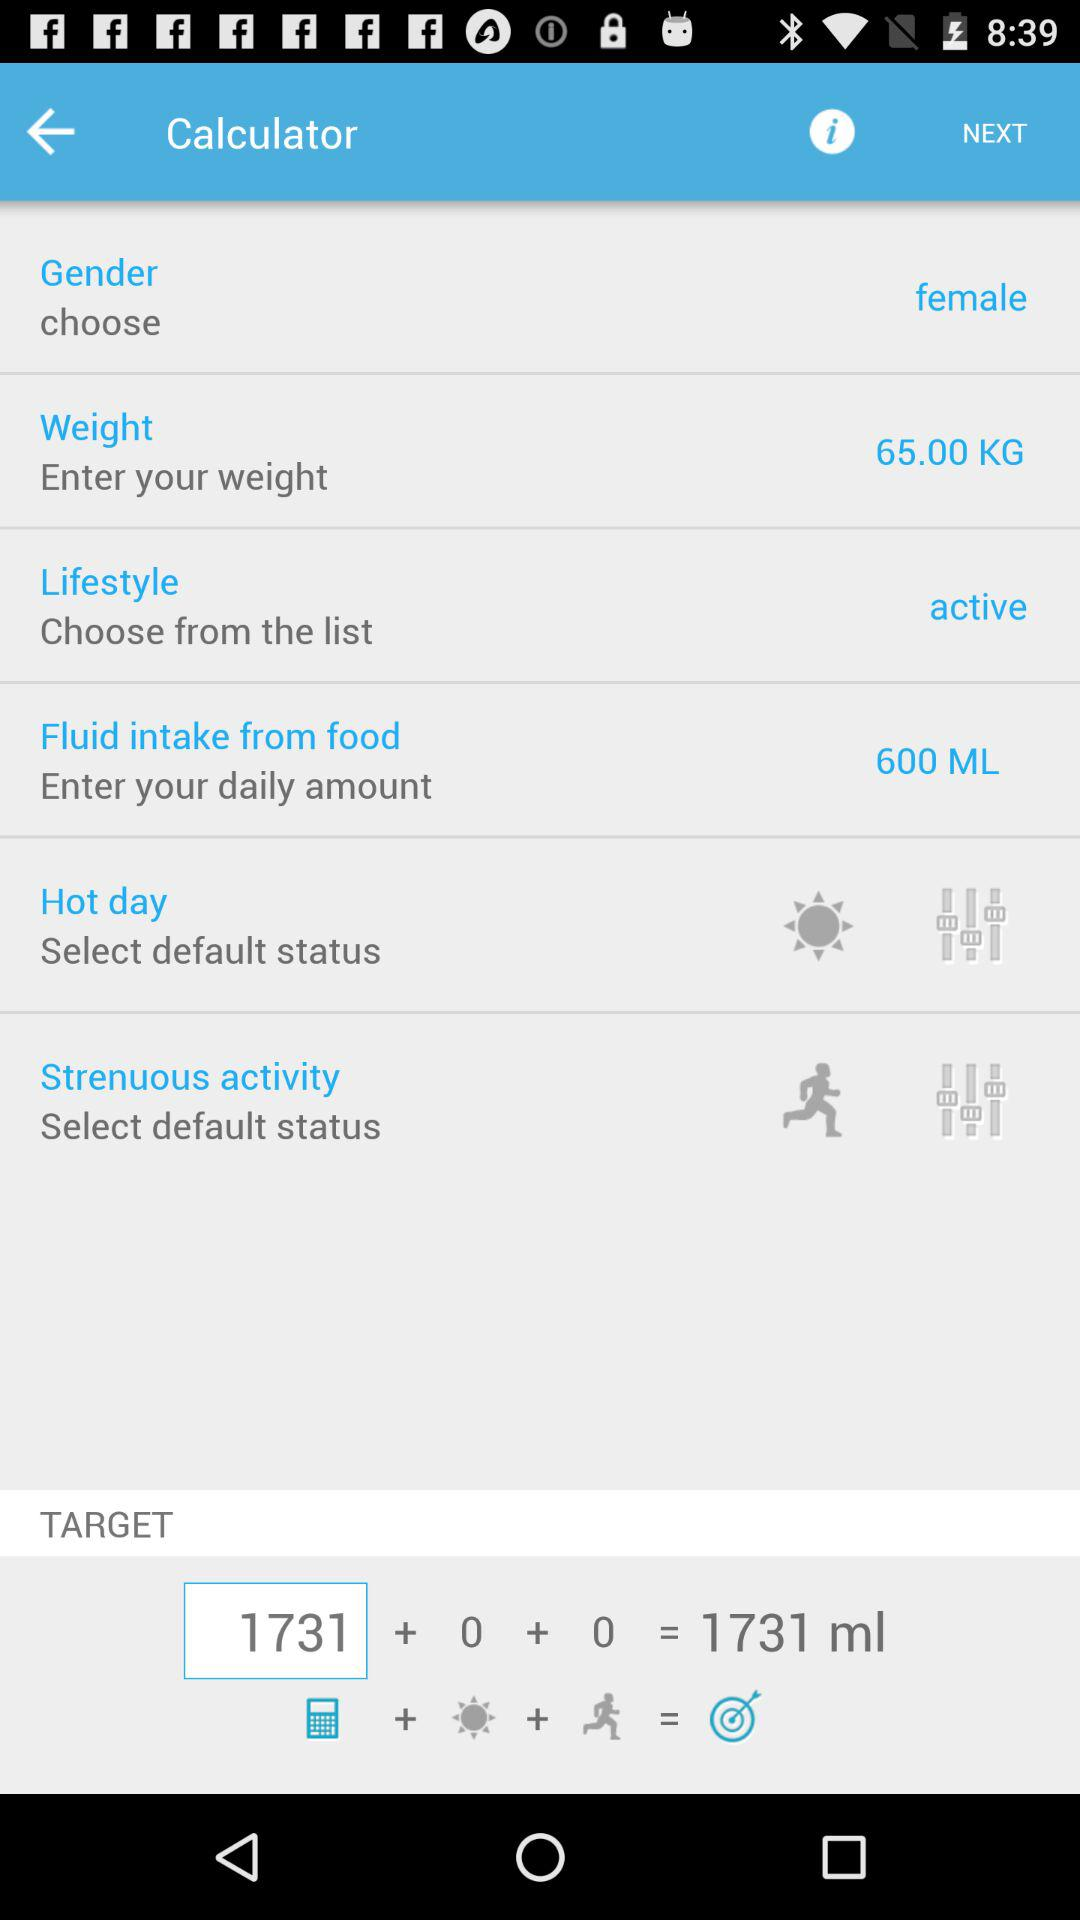What is the daily amount shown on the screen? The daily amount is 600 milliliters. 